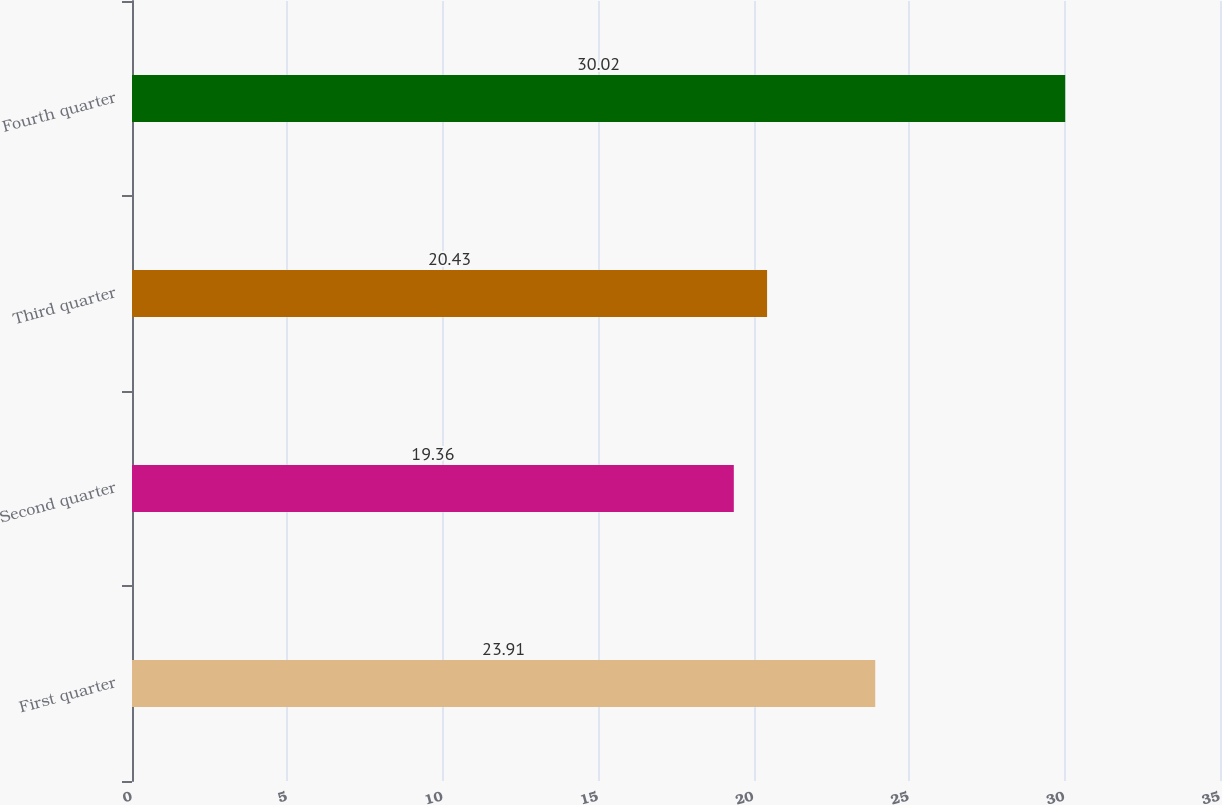Convert chart to OTSL. <chart><loc_0><loc_0><loc_500><loc_500><bar_chart><fcel>First quarter<fcel>Second quarter<fcel>Third quarter<fcel>Fourth quarter<nl><fcel>23.91<fcel>19.36<fcel>20.43<fcel>30.02<nl></chart> 